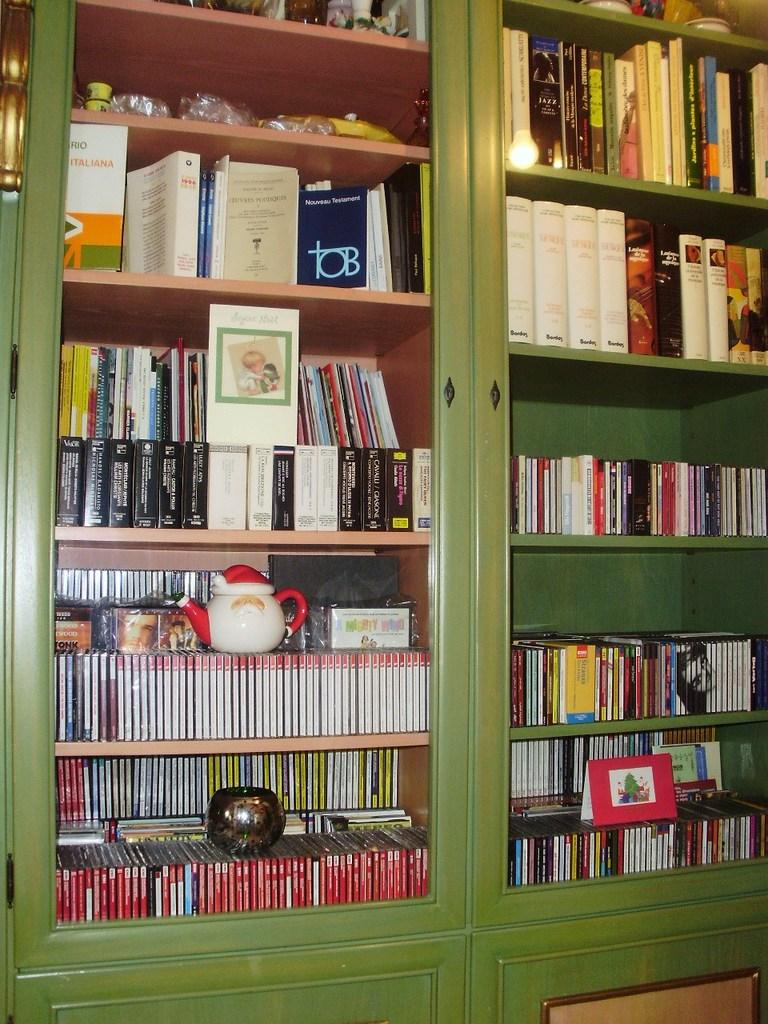Provide a one-sentence caption for the provided image. A large green shelf unit includes an Italian version of the New Testament. 